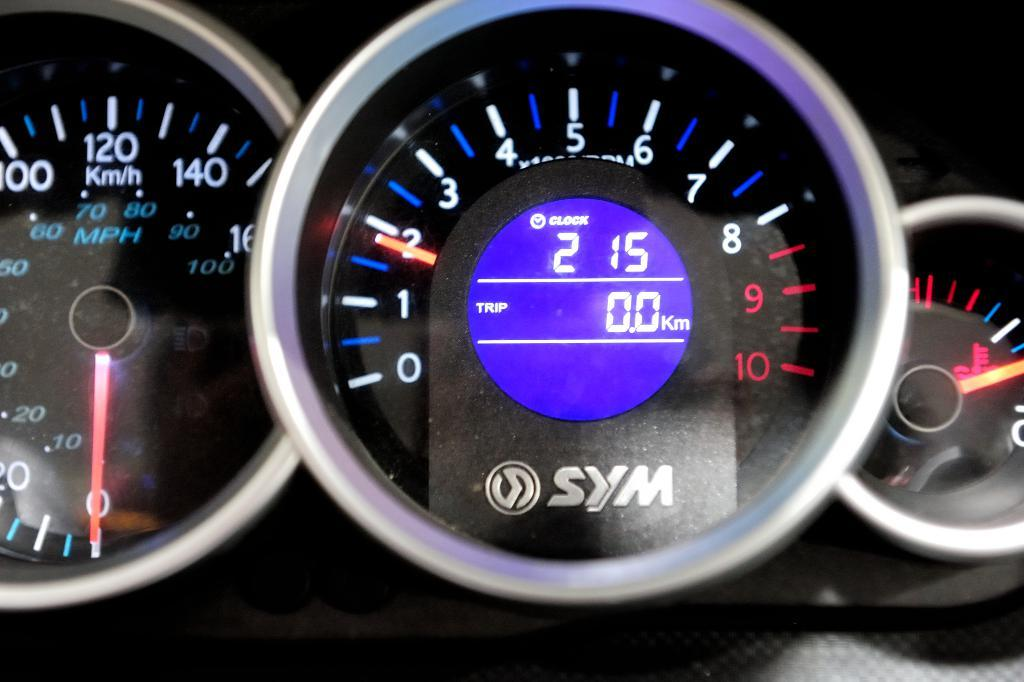What is the main object in the image? There is a speedometer in the image. What is the primary function of the speedometer? The speedometer is used to measure and display the speed of a vehicle. Can you describe the appearance of the speedometer? The appearance of the speedometer may vary depending on the vehicle it belongs to, but it typically consists of a dial with numbers indicating different speeds. What color is the tail of the speedometer in the image? There is no tail present on the speedometer in the image. 